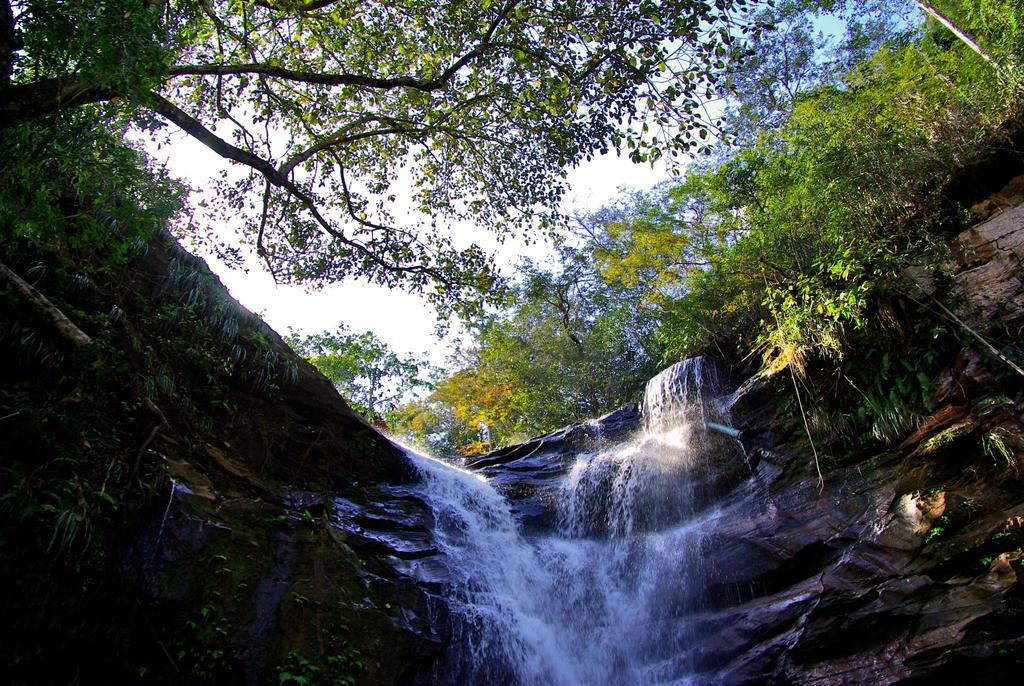Where was the picture taken? The picture was clicked outside. What is the main feature in the center of the image? There is a waterfall in the center of the image. What type of natural formations can be seen in the image? Rocks are visible in the image. What other types of vegetation are present in the image? There are plants in the image. What can be seen in the background of the image? The sky and trees are visible in the background of the image. Who won the competition that took place near the waterfall in the image? There is no competition present in the image, so it is not possible to determine a winner. Can you tell me how many porters are carrying the luggage near the waterfall in the image? There are no porters or luggage present in the image; it features a waterfall, rocks, plants, and trees. 